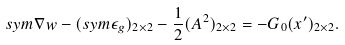<formula> <loc_0><loc_0><loc_500><loc_500>s y m \nabla w - ( s y m \epsilon _ { g } ) _ { 2 \times 2 } - \frac { 1 } { 2 } ( A ^ { 2 } ) _ { 2 \times 2 } = - G _ { 0 } ( x ^ { \prime } ) _ { 2 \times 2 } .</formula> 